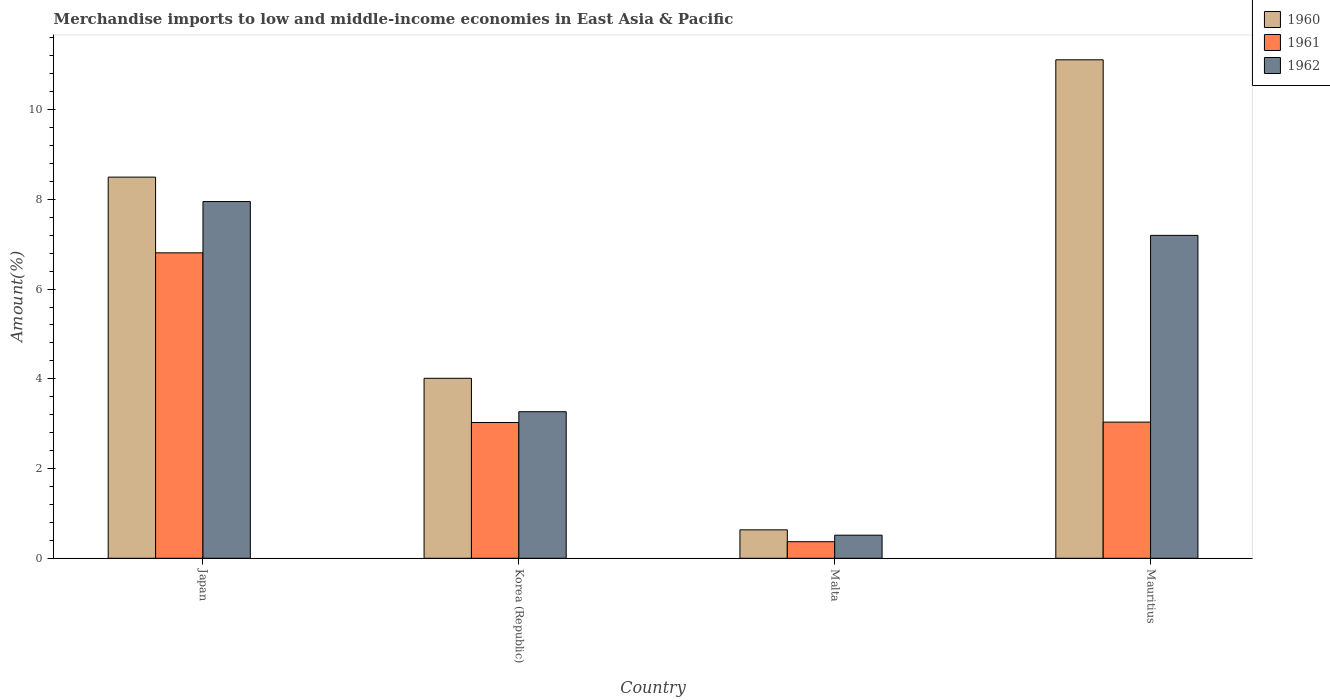Are the number of bars per tick equal to the number of legend labels?
Offer a terse response. Yes. Are the number of bars on each tick of the X-axis equal?
Ensure brevity in your answer.  Yes. What is the label of the 3rd group of bars from the left?
Make the answer very short. Malta. What is the percentage of amount earned from merchandise imports in 1961 in Japan?
Give a very brief answer. 6.81. Across all countries, what is the maximum percentage of amount earned from merchandise imports in 1960?
Keep it short and to the point. 11.11. Across all countries, what is the minimum percentage of amount earned from merchandise imports in 1960?
Provide a succinct answer. 0.63. In which country was the percentage of amount earned from merchandise imports in 1962 minimum?
Ensure brevity in your answer.  Malta. What is the total percentage of amount earned from merchandise imports in 1960 in the graph?
Ensure brevity in your answer.  24.25. What is the difference between the percentage of amount earned from merchandise imports in 1961 in Japan and that in Mauritius?
Offer a terse response. 3.77. What is the difference between the percentage of amount earned from merchandise imports in 1961 in Mauritius and the percentage of amount earned from merchandise imports in 1962 in Malta?
Provide a succinct answer. 2.52. What is the average percentage of amount earned from merchandise imports in 1961 per country?
Offer a terse response. 3.31. What is the difference between the percentage of amount earned from merchandise imports of/in 1961 and percentage of amount earned from merchandise imports of/in 1962 in Japan?
Ensure brevity in your answer.  -1.14. In how many countries, is the percentage of amount earned from merchandise imports in 1960 greater than 3.6 %?
Provide a succinct answer. 3. What is the ratio of the percentage of amount earned from merchandise imports in 1961 in Malta to that in Mauritius?
Your response must be concise. 0.12. Is the percentage of amount earned from merchandise imports in 1961 in Japan less than that in Malta?
Offer a terse response. No. What is the difference between the highest and the second highest percentage of amount earned from merchandise imports in 1960?
Your answer should be compact. -2.62. What is the difference between the highest and the lowest percentage of amount earned from merchandise imports in 1962?
Your response must be concise. 7.44. What does the 1st bar from the right in Malta represents?
Provide a succinct answer. 1962. Are all the bars in the graph horizontal?
Offer a very short reply. No. How many countries are there in the graph?
Provide a short and direct response. 4. What is the difference between two consecutive major ticks on the Y-axis?
Ensure brevity in your answer.  2. Does the graph contain any zero values?
Your response must be concise. No. Does the graph contain grids?
Keep it short and to the point. No. Where does the legend appear in the graph?
Offer a very short reply. Top right. What is the title of the graph?
Make the answer very short. Merchandise imports to low and middle-income economies in East Asia & Pacific. What is the label or title of the X-axis?
Provide a short and direct response. Country. What is the label or title of the Y-axis?
Your answer should be very brief. Amount(%). What is the Amount(%) in 1960 in Japan?
Your answer should be very brief. 8.5. What is the Amount(%) in 1961 in Japan?
Give a very brief answer. 6.81. What is the Amount(%) in 1962 in Japan?
Offer a terse response. 7.95. What is the Amount(%) of 1960 in Korea (Republic)?
Offer a very short reply. 4.01. What is the Amount(%) in 1961 in Korea (Republic)?
Provide a succinct answer. 3.03. What is the Amount(%) of 1962 in Korea (Republic)?
Keep it short and to the point. 3.27. What is the Amount(%) of 1960 in Malta?
Your response must be concise. 0.63. What is the Amount(%) in 1961 in Malta?
Provide a succinct answer. 0.37. What is the Amount(%) of 1962 in Malta?
Provide a succinct answer. 0.51. What is the Amount(%) of 1960 in Mauritius?
Give a very brief answer. 11.11. What is the Amount(%) in 1961 in Mauritius?
Your response must be concise. 3.03. What is the Amount(%) of 1962 in Mauritius?
Keep it short and to the point. 7.2. Across all countries, what is the maximum Amount(%) in 1960?
Give a very brief answer. 11.11. Across all countries, what is the maximum Amount(%) of 1961?
Your answer should be very brief. 6.81. Across all countries, what is the maximum Amount(%) in 1962?
Your answer should be compact. 7.95. Across all countries, what is the minimum Amount(%) in 1960?
Keep it short and to the point. 0.63. Across all countries, what is the minimum Amount(%) of 1961?
Your answer should be very brief. 0.37. Across all countries, what is the minimum Amount(%) in 1962?
Provide a short and direct response. 0.51. What is the total Amount(%) in 1960 in the graph?
Ensure brevity in your answer.  24.25. What is the total Amount(%) in 1961 in the graph?
Give a very brief answer. 13.24. What is the total Amount(%) of 1962 in the graph?
Your response must be concise. 18.93. What is the difference between the Amount(%) in 1960 in Japan and that in Korea (Republic)?
Your answer should be compact. 4.48. What is the difference between the Amount(%) of 1961 in Japan and that in Korea (Republic)?
Ensure brevity in your answer.  3.78. What is the difference between the Amount(%) of 1962 in Japan and that in Korea (Republic)?
Provide a succinct answer. 4.68. What is the difference between the Amount(%) in 1960 in Japan and that in Malta?
Provide a succinct answer. 7.86. What is the difference between the Amount(%) in 1961 in Japan and that in Malta?
Your response must be concise. 6.44. What is the difference between the Amount(%) in 1962 in Japan and that in Malta?
Provide a short and direct response. 7.44. What is the difference between the Amount(%) in 1960 in Japan and that in Mauritius?
Ensure brevity in your answer.  -2.62. What is the difference between the Amount(%) in 1961 in Japan and that in Mauritius?
Give a very brief answer. 3.77. What is the difference between the Amount(%) of 1962 in Japan and that in Mauritius?
Your answer should be compact. 0.75. What is the difference between the Amount(%) of 1960 in Korea (Republic) and that in Malta?
Give a very brief answer. 3.38. What is the difference between the Amount(%) of 1961 in Korea (Republic) and that in Malta?
Your answer should be very brief. 2.66. What is the difference between the Amount(%) of 1962 in Korea (Republic) and that in Malta?
Offer a terse response. 2.75. What is the difference between the Amount(%) of 1960 in Korea (Republic) and that in Mauritius?
Offer a terse response. -7.1. What is the difference between the Amount(%) in 1961 in Korea (Republic) and that in Mauritius?
Your answer should be very brief. -0.01. What is the difference between the Amount(%) of 1962 in Korea (Republic) and that in Mauritius?
Ensure brevity in your answer.  -3.93. What is the difference between the Amount(%) in 1960 in Malta and that in Mauritius?
Keep it short and to the point. -10.48. What is the difference between the Amount(%) of 1961 in Malta and that in Mauritius?
Give a very brief answer. -2.67. What is the difference between the Amount(%) in 1962 in Malta and that in Mauritius?
Your answer should be very brief. -6.68. What is the difference between the Amount(%) of 1960 in Japan and the Amount(%) of 1961 in Korea (Republic)?
Provide a succinct answer. 5.47. What is the difference between the Amount(%) of 1960 in Japan and the Amount(%) of 1962 in Korea (Republic)?
Provide a succinct answer. 5.23. What is the difference between the Amount(%) of 1961 in Japan and the Amount(%) of 1962 in Korea (Republic)?
Provide a short and direct response. 3.54. What is the difference between the Amount(%) in 1960 in Japan and the Amount(%) in 1961 in Malta?
Offer a very short reply. 8.13. What is the difference between the Amount(%) of 1960 in Japan and the Amount(%) of 1962 in Malta?
Keep it short and to the point. 7.98. What is the difference between the Amount(%) of 1961 in Japan and the Amount(%) of 1962 in Malta?
Your answer should be compact. 6.29. What is the difference between the Amount(%) of 1960 in Japan and the Amount(%) of 1961 in Mauritius?
Give a very brief answer. 5.46. What is the difference between the Amount(%) in 1960 in Japan and the Amount(%) in 1962 in Mauritius?
Offer a terse response. 1.3. What is the difference between the Amount(%) in 1961 in Japan and the Amount(%) in 1962 in Mauritius?
Keep it short and to the point. -0.39. What is the difference between the Amount(%) of 1960 in Korea (Republic) and the Amount(%) of 1961 in Malta?
Ensure brevity in your answer.  3.64. What is the difference between the Amount(%) in 1960 in Korea (Republic) and the Amount(%) in 1962 in Malta?
Provide a short and direct response. 3.5. What is the difference between the Amount(%) of 1961 in Korea (Republic) and the Amount(%) of 1962 in Malta?
Make the answer very short. 2.51. What is the difference between the Amount(%) in 1960 in Korea (Republic) and the Amount(%) in 1961 in Mauritius?
Offer a very short reply. 0.98. What is the difference between the Amount(%) in 1960 in Korea (Republic) and the Amount(%) in 1962 in Mauritius?
Keep it short and to the point. -3.19. What is the difference between the Amount(%) in 1961 in Korea (Republic) and the Amount(%) in 1962 in Mauritius?
Offer a terse response. -4.17. What is the difference between the Amount(%) of 1960 in Malta and the Amount(%) of 1961 in Mauritius?
Offer a very short reply. -2.4. What is the difference between the Amount(%) in 1960 in Malta and the Amount(%) in 1962 in Mauritius?
Provide a short and direct response. -6.56. What is the difference between the Amount(%) of 1961 in Malta and the Amount(%) of 1962 in Mauritius?
Keep it short and to the point. -6.83. What is the average Amount(%) of 1960 per country?
Your response must be concise. 6.06. What is the average Amount(%) in 1961 per country?
Keep it short and to the point. 3.31. What is the average Amount(%) in 1962 per country?
Your answer should be very brief. 4.73. What is the difference between the Amount(%) in 1960 and Amount(%) in 1961 in Japan?
Keep it short and to the point. 1.69. What is the difference between the Amount(%) in 1960 and Amount(%) in 1962 in Japan?
Offer a very short reply. 0.54. What is the difference between the Amount(%) in 1961 and Amount(%) in 1962 in Japan?
Ensure brevity in your answer.  -1.14. What is the difference between the Amount(%) of 1960 and Amount(%) of 1961 in Korea (Republic)?
Your response must be concise. 0.99. What is the difference between the Amount(%) of 1960 and Amount(%) of 1962 in Korea (Republic)?
Give a very brief answer. 0.74. What is the difference between the Amount(%) in 1961 and Amount(%) in 1962 in Korea (Republic)?
Give a very brief answer. -0.24. What is the difference between the Amount(%) in 1960 and Amount(%) in 1961 in Malta?
Your answer should be compact. 0.26. What is the difference between the Amount(%) in 1960 and Amount(%) in 1962 in Malta?
Your answer should be very brief. 0.12. What is the difference between the Amount(%) in 1961 and Amount(%) in 1962 in Malta?
Give a very brief answer. -0.15. What is the difference between the Amount(%) of 1960 and Amount(%) of 1961 in Mauritius?
Make the answer very short. 8.08. What is the difference between the Amount(%) in 1960 and Amount(%) in 1962 in Mauritius?
Offer a terse response. 3.91. What is the difference between the Amount(%) in 1961 and Amount(%) in 1962 in Mauritius?
Your answer should be very brief. -4.16. What is the ratio of the Amount(%) in 1960 in Japan to that in Korea (Republic)?
Offer a terse response. 2.12. What is the ratio of the Amount(%) in 1961 in Japan to that in Korea (Republic)?
Keep it short and to the point. 2.25. What is the ratio of the Amount(%) in 1962 in Japan to that in Korea (Republic)?
Provide a succinct answer. 2.43. What is the ratio of the Amount(%) of 1960 in Japan to that in Malta?
Offer a very short reply. 13.41. What is the ratio of the Amount(%) of 1961 in Japan to that in Malta?
Provide a short and direct response. 18.43. What is the ratio of the Amount(%) in 1962 in Japan to that in Malta?
Ensure brevity in your answer.  15.45. What is the ratio of the Amount(%) in 1960 in Japan to that in Mauritius?
Your answer should be very brief. 0.76. What is the ratio of the Amount(%) in 1961 in Japan to that in Mauritius?
Offer a very short reply. 2.24. What is the ratio of the Amount(%) of 1962 in Japan to that in Mauritius?
Ensure brevity in your answer.  1.1. What is the ratio of the Amount(%) of 1960 in Korea (Republic) to that in Malta?
Ensure brevity in your answer.  6.33. What is the ratio of the Amount(%) of 1961 in Korea (Republic) to that in Malta?
Provide a succinct answer. 8.19. What is the ratio of the Amount(%) in 1962 in Korea (Republic) to that in Malta?
Provide a short and direct response. 6.35. What is the ratio of the Amount(%) of 1960 in Korea (Republic) to that in Mauritius?
Make the answer very short. 0.36. What is the ratio of the Amount(%) in 1961 in Korea (Republic) to that in Mauritius?
Give a very brief answer. 1. What is the ratio of the Amount(%) in 1962 in Korea (Republic) to that in Mauritius?
Ensure brevity in your answer.  0.45. What is the ratio of the Amount(%) of 1960 in Malta to that in Mauritius?
Offer a terse response. 0.06. What is the ratio of the Amount(%) of 1961 in Malta to that in Mauritius?
Offer a terse response. 0.12. What is the ratio of the Amount(%) of 1962 in Malta to that in Mauritius?
Provide a short and direct response. 0.07. What is the difference between the highest and the second highest Amount(%) in 1960?
Offer a terse response. 2.62. What is the difference between the highest and the second highest Amount(%) of 1961?
Provide a short and direct response. 3.77. What is the difference between the highest and the second highest Amount(%) in 1962?
Give a very brief answer. 0.75. What is the difference between the highest and the lowest Amount(%) in 1960?
Ensure brevity in your answer.  10.48. What is the difference between the highest and the lowest Amount(%) of 1961?
Provide a succinct answer. 6.44. What is the difference between the highest and the lowest Amount(%) of 1962?
Your response must be concise. 7.44. 